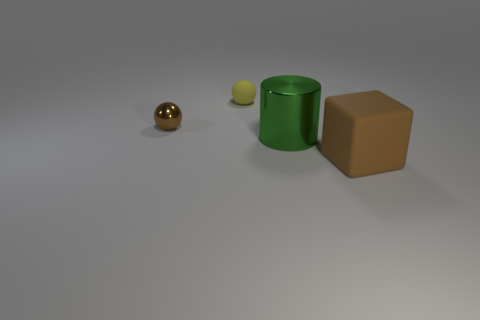Add 3 metallic spheres. How many objects exist? 7 Subtract all cylinders. How many objects are left? 3 Subtract all small green rubber objects. Subtract all yellow matte spheres. How many objects are left? 3 Add 2 green metal cylinders. How many green metal cylinders are left? 3 Add 4 small purple metallic cylinders. How many small purple metallic cylinders exist? 4 Subtract 0 gray balls. How many objects are left? 4 